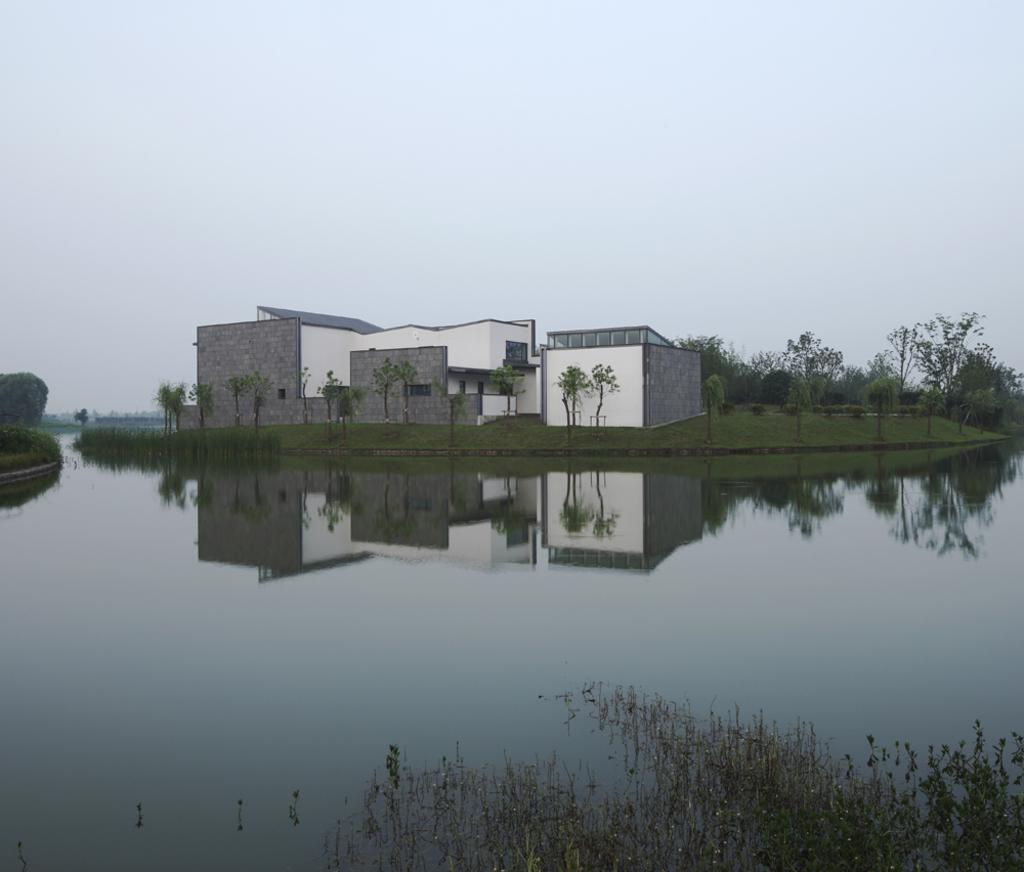What is the primary element visible in the image? There is water in the image. What other living organisms can be seen in the image? There are plants in the image. What can be seen in the distance in the background of the image? There are trees and buildings in the background of the image. What color is the ball floating on the water in the image? There is no ball present in the image; it only features water, plants, trees, and buildings. 